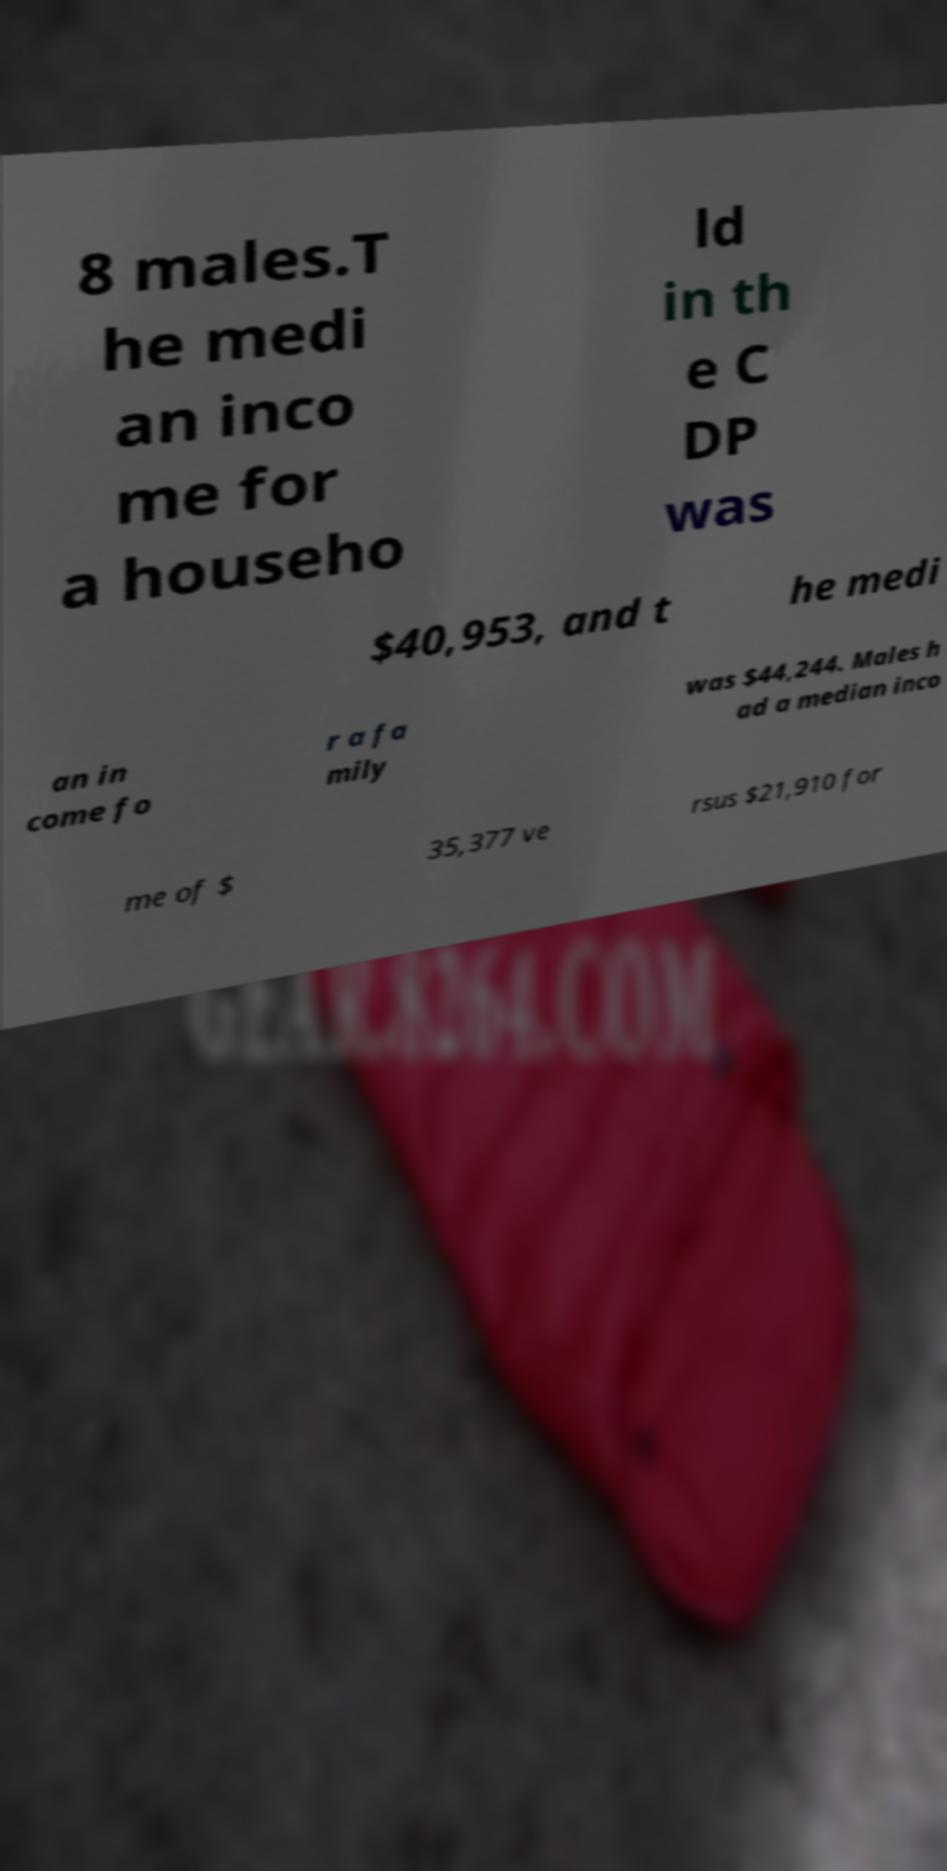Please identify and transcribe the text found in this image. 8 males.T he medi an inco me for a househo ld in th e C DP was $40,953, and t he medi an in come fo r a fa mily was $44,244. Males h ad a median inco me of $ 35,377 ve rsus $21,910 for 